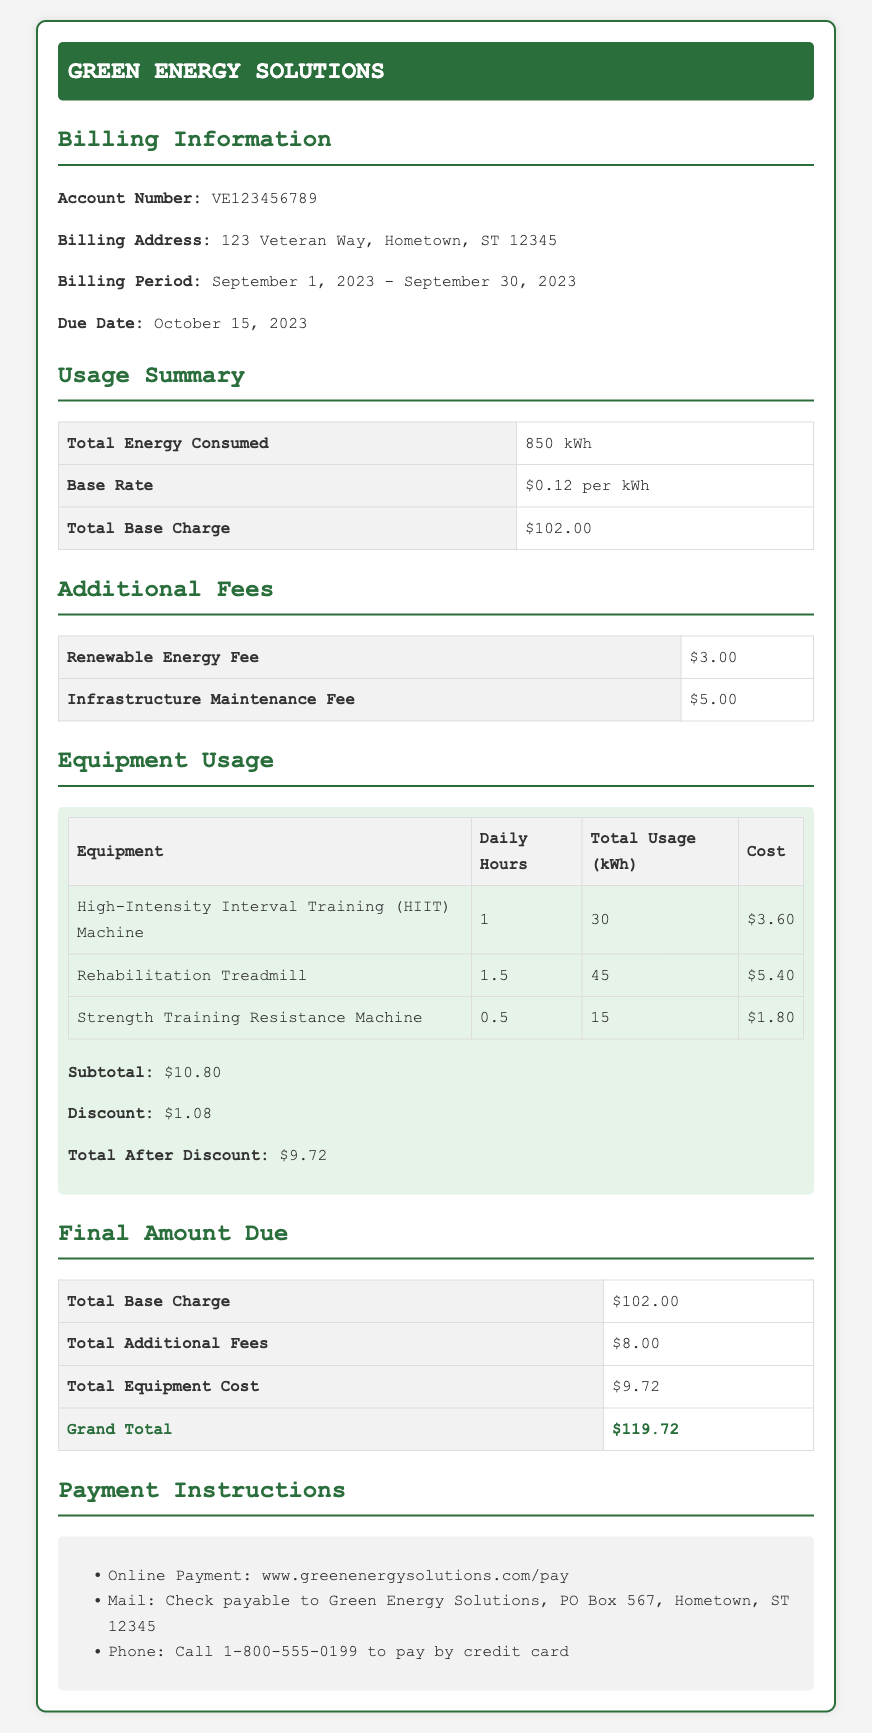What is the billing address? The billing address is clearly stated in the document as "123 Veteran Way, Hometown, ST 12345."
Answer: 123 Veteran Way, Hometown, ST 12345 What is the billing period? The billing period is indicated as "September 1, 2023 - September 30, 2023."
Answer: September 1, 2023 - September 30, 2023 How much is the renewable energy fee? The renewable energy fee is listed under Additional Fees as "$3.00."
Answer: $3.00 What is the total energy consumed? The total energy consumed for the billing period is mentioned as "850 kWh."
Answer: 850 kWh What is the total cost for the Rehabilitation Treadmill? The total cost for the Rehabilitation Treadmill shown in the Equipment Usage section is "$5.40."
Answer: $5.40 What is the discount provided for equipment usage? The document states the discount for equipment usage as "$1.08."
Answer: $1.08 What is the grand total amount due? The grand total amount due is clearly stated at the end of the bill as "$119.72."
Answer: $119.72 What method is suggested for online payment? The document specifies that online payment can be made via the website mentioned as "www.greenenergysolutions.com/pay."
Answer: www.greenenergysolutions.com/pay How many kWh does the HIIT Machine consume in total? The total usage for the HIIT Machine is listed as "30 kWh."
Answer: 30 kWh 